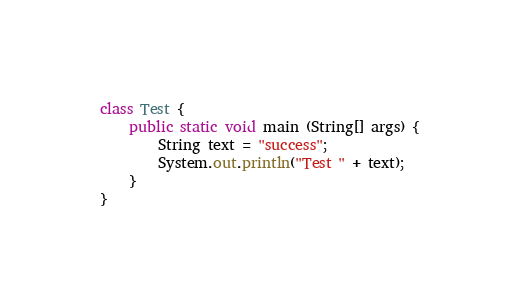<code> <loc_0><loc_0><loc_500><loc_500><_Java_>class Test {
	public static void main (String[] args) {
		String text = "success";
		System.out.println("Test " + text);
	}
}</code> 